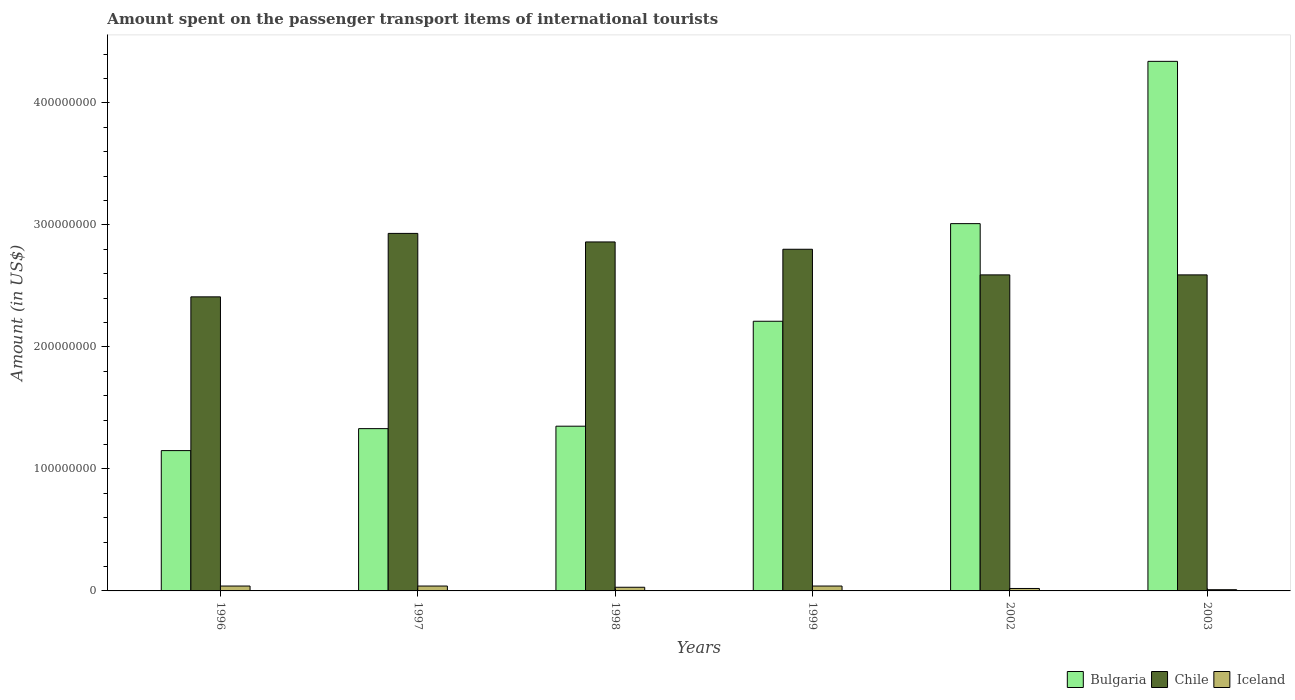How many groups of bars are there?
Your answer should be very brief. 6. Are the number of bars per tick equal to the number of legend labels?
Offer a very short reply. Yes. Are the number of bars on each tick of the X-axis equal?
Your answer should be very brief. Yes. How many bars are there on the 4th tick from the left?
Give a very brief answer. 3. How many bars are there on the 4th tick from the right?
Provide a short and direct response. 3. In how many cases, is the number of bars for a given year not equal to the number of legend labels?
Provide a short and direct response. 0. What is the amount spent on the passenger transport items of international tourists in Bulgaria in 2003?
Make the answer very short. 4.34e+08. Across all years, what is the maximum amount spent on the passenger transport items of international tourists in Bulgaria?
Your answer should be very brief. 4.34e+08. Across all years, what is the minimum amount spent on the passenger transport items of international tourists in Bulgaria?
Provide a short and direct response. 1.15e+08. What is the total amount spent on the passenger transport items of international tourists in Chile in the graph?
Offer a terse response. 1.62e+09. What is the difference between the amount spent on the passenger transport items of international tourists in Bulgaria in 2002 and that in 2003?
Give a very brief answer. -1.33e+08. What is the difference between the amount spent on the passenger transport items of international tourists in Iceland in 1999 and the amount spent on the passenger transport items of international tourists in Bulgaria in 1996?
Ensure brevity in your answer.  -1.11e+08. What is the average amount spent on the passenger transport items of international tourists in Iceland per year?
Keep it short and to the point. 3.00e+06. In the year 2003, what is the difference between the amount spent on the passenger transport items of international tourists in Iceland and amount spent on the passenger transport items of international tourists in Bulgaria?
Your response must be concise. -4.33e+08. In how many years, is the amount spent on the passenger transport items of international tourists in Bulgaria greater than 220000000 US$?
Provide a succinct answer. 3. What is the ratio of the amount spent on the passenger transport items of international tourists in Bulgaria in 2002 to that in 2003?
Your answer should be compact. 0.69. Is the amount spent on the passenger transport items of international tourists in Bulgaria in 1997 less than that in 2003?
Keep it short and to the point. Yes. Is the difference between the amount spent on the passenger transport items of international tourists in Iceland in 1996 and 1998 greater than the difference between the amount spent on the passenger transport items of international tourists in Bulgaria in 1996 and 1998?
Ensure brevity in your answer.  Yes. What is the difference between the highest and the second highest amount spent on the passenger transport items of international tourists in Iceland?
Your answer should be very brief. 0. What is the difference between the highest and the lowest amount spent on the passenger transport items of international tourists in Iceland?
Offer a very short reply. 3.00e+06. In how many years, is the amount spent on the passenger transport items of international tourists in Bulgaria greater than the average amount spent on the passenger transport items of international tourists in Bulgaria taken over all years?
Give a very brief answer. 2. Is the sum of the amount spent on the passenger transport items of international tourists in Bulgaria in 1999 and 2002 greater than the maximum amount spent on the passenger transport items of international tourists in Iceland across all years?
Offer a terse response. Yes. What does the 2nd bar from the left in 2003 represents?
Your response must be concise. Chile. What does the 2nd bar from the right in 1997 represents?
Provide a succinct answer. Chile. Is it the case that in every year, the sum of the amount spent on the passenger transport items of international tourists in Chile and amount spent on the passenger transport items of international tourists in Iceland is greater than the amount spent on the passenger transport items of international tourists in Bulgaria?
Give a very brief answer. No. Are all the bars in the graph horizontal?
Ensure brevity in your answer.  No. How many years are there in the graph?
Your answer should be compact. 6. What is the difference between two consecutive major ticks on the Y-axis?
Provide a succinct answer. 1.00e+08. Does the graph contain any zero values?
Your response must be concise. No. Does the graph contain grids?
Provide a succinct answer. No. Where does the legend appear in the graph?
Give a very brief answer. Bottom right. What is the title of the graph?
Offer a very short reply. Amount spent on the passenger transport items of international tourists. What is the label or title of the X-axis?
Offer a very short reply. Years. What is the Amount (in US$) in Bulgaria in 1996?
Your response must be concise. 1.15e+08. What is the Amount (in US$) of Chile in 1996?
Your response must be concise. 2.41e+08. What is the Amount (in US$) of Bulgaria in 1997?
Your answer should be very brief. 1.33e+08. What is the Amount (in US$) of Chile in 1997?
Provide a succinct answer. 2.93e+08. What is the Amount (in US$) in Iceland in 1997?
Your answer should be compact. 4.00e+06. What is the Amount (in US$) of Bulgaria in 1998?
Provide a succinct answer. 1.35e+08. What is the Amount (in US$) in Chile in 1998?
Your answer should be very brief. 2.86e+08. What is the Amount (in US$) in Bulgaria in 1999?
Your answer should be compact. 2.21e+08. What is the Amount (in US$) in Chile in 1999?
Your answer should be very brief. 2.80e+08. What is the Amount (in US$) of Iceland in 1999?
Provide a succinct answer. 4.00e+06. What is the Amount (in US$) of Bulgaria in 2002?
Your response must be concise. 3.01e+08. What is the Amount (in US$) in Chile in 2002?
Offer a terse response. 2.59e+08. What is the Amount (in US$) of Iceland in 2002?
Keep it short and to the point. 2.00e+06. What is the Amount (in US$) in Bulgaria in 2003?
Keep it short and to the point. 4.34e+08. What is the Amount (in US$) of Chile in 2003?
Your answer should be compact. 2.59e+08. What is the Amount (in US$) of Iceland in 2003?
Provide a short and direct response. 1.00e+06. Across all years, what is the maximum Amount (in US$) in Bulgaria?
Provide a short and direct response. 4.34e+08. Across all years, what is the maximum Amount (in US$) of Chile?
Keep it short and to the point. 2.93e+08. Across all years, what is the maximum Amount (in US$) in Iceland?
Your answer should be compact. 4.00e+06. Across all years, what is the minimum Amount (in US$) in Bulgaria?
Give a very brief answer. 1.15e+08. Across all years, what is the minimum Amount (in US$) of Chile?
Your answer should be very brief. 2.41e+08. What is the total Amount (in US$) in Bulgaria in the graph?
Give a very brief answer. 1.34e+09. What is the total Amount (in US$) of Chile in the graph?
Make the answer very short. 1.62e+09. What is the total Amount (in US$) of Iceland in the graph?
Provide a succinct answer. 1.80e+07. What is the difference between the Amount (in US$) of Bulgaria in 1996 and that in 1997?
Keep it short and to the point. -1.80e+07. What is the difference between the Amount (in US$) of Chile in 1996 and that in 1997?
Your response must be concise. -5.20e+07. What is the difference between the Amount (in US$) of Bulgaria in 1996 and that in 1998?
Give a very brief answer. -2.00e+07. What is the difference between the Amount (in US$) in Chile in 1996 and that in 1998?
Offer a terse response. -4.50e+07. What is the difference between the Amount (in US$) of Iceland in 1996 and that in 1998?
Give a very brief answer. 1.00e+06. What is the difference between the Amount (in US$) of Bulgaria in 1996 and that in 1999?
Your response must be concise. -1.06e+08. What is the difference between the Amount (in US$) of Chile in 1996 and that in 1999?
Give a very brief answer. -3.90e+07. What is the difference between the Amount (in US$) of Bulgaria in 1996 and that in 2002?
Your response must be concise. -1.86e+08. What is the difference between the Amount (in US$) in Chile in 1996 and that in 2002?
Your answer should be very brief. -1.80e+07. What is the difference between the Amount (in US$) of Bulgaria in 1996 and that in 2003?
Offer a very short reply. -3.19e+08. What is the difference between the Amount (in US$) in Chile in 1996 and that in 2003?
Your response must be concise. -1.80e+07. What is the difference between the Amount (in US$) in Iceland in 1996 and that in 2003?
Make the answer very short. 3.00e+06. What is the difference between the Amount (in US$) in Chile in 1997 and that in 1998?
Offer a very short reply. 7.00e+06. What is the difference between the Amount (in US$) of Iceland in 1997 and that in 1998?
Provide a succinct answer. 1.00e+06. What is the difference between the Amount (in US$) of Bulgaria in 1997 and that in 1999?
Your answer should be very brief. -8.80e+07. What is the difference between the Amount (in US$) in Chile in 1997 and that in 1999?
Provide a short and direct response. 1.30e+07. What is the difference between the Amount (in US$) in Iceland in 1997 and that in 1999?
Ensure brevity in your answer.  0. What is the difference between the Amount (in US$) of Bulgaria in 1997 and that in 2002?
Make the answer very short. -1.68e+08. What is the difference between the Amount (in US$) in Chile in 1997 and that in 2002?
Keep it short and to the point. 3.40e+07. What is the difference between the Amount (in US$) of Iceland in 1997 and that in 2002?
Keep it short and to the point. 2.00e+06. What is the difference between the Amount (in US$) of Bulgaria in 1997 and that in 2003?
Provide a short and direct response. -3.01e+08. What is the difference between the Amount (in US$) of Chile in 1997 and that in 2003?
Your response must be concise. 3.40e+07. What is the difference between the Amount (in US$) in Iceland in 1997 and that in 2003?
Your answer should be compact. 3.00e+06. What is the difference between the Amount (in US$) in Bulgaria in 1998 and that in 1999?
Keep it short and to the point. -8.60e+07. What is the difference between the Amount (in US$) in Bulgaria in 1998 and that in 2002?
Provide a short and direct response. -1.66e+08. What is the difference between the Amount (in US$) in Chile in 1998 and that in 2002?
Offer a very short reply. 2.70e+07. What is the difference between the Amount (in US$) of Bulgaria in 1998 and that in 2003?
Provide a succinct answer. -2.99e+08. What is the difference between the Amount (in US$) in Chile in 1998 and that in 2003?
Give a very brief answer. 2.70e+07. What is the difference between the Amount (in US$) of Iceland in 1998 and that in 2003?
Your answer should be very brief. 2.00e+06. What is the difference between the Amount (in US$) of Bulgaria in 1999 and that in 2002?
Offer a very short reply. -8.00e+07. What is the difference between the Amount (in US$) in Chile in 1999 and that in 2002?
Your answer should be compact. 2.10e+07. What is the difference between the Amount (in US$) in Bulgaria in 1999 and that in 2003?
Offer a very short reply. -2.13e+08. What is the difference between the Amount (in US$) in Chile in 1999 and that in 2003?
Ensure brevity in your answer.  2.10e+07. What is the difference between the Amount (in US$) of Bulgaria in 2002 and that in 2003?
Keep it short and to the point. -1.33e+08. What is the difference between the Amount (in US$) in Chile in 2002 and that in 2003?
Give a very brief answer. 0. What is the difference between the Amount (in US$) in Iceland in 2002 and that in 2003?
Your answer should be very brief. 1.00e+06. What is the difference between the Amount (in US$) in Bulgaria in 1996 and the Amount (in US$) in Chile in 1997?
Make the answer very short. -1.78e+08. What is the difference between the Amount (in US$) of Bulgaria in 1996 and the Amount (in US$) of Iceland in 1997?
Your answer should be very brief. 1.11e+08. What is the difference between the Amount (in US$) in Chile in 1996 and the Amount (in US$) in Iceland in 1997?
Your answer should be very brief. 2.37e+08. What is the difference between the Amount (in US$) in Bulgaria in 1996 and the Amount (in US$) in Chile in 1998?
Provide a short and direct response. -1.71e+08. What is the difference between the Amount (in US$) of Bulgaria in 1996 and the Amount (in US$) of Iceland in 1998?
Give a very brief answer. 1.12e+08. What is the difference between the Amount (in US$) in Chile in 1996 and the Amount (in US$) in Iceland in 1998?
Your answer should be compact. 2.38e+08. What is the difference between the Amount (in US$) of Bulgaria in 1996 and the Amount (in US$) of Chile in 1999?
Provide a short and direct response. -1.65e+08. What is the difference between the Amount (in US$) of Bulgaria in 1996 and the Amount (in US$) of Iceland in 1999?
Keep it short and to the point. 1.11e+08. What is the difference between the Amount (in US$) in Chile in 1996 and the Amount (in US$) in Iceland in 1999?
Ensure brevity in your answer.  2.37e+08. What is the difference between the Amount (in US$) in Bulgaria in 1996 and the Amount (in US$) in Chile in 2002?
Your response must be concise. -1.44e+08. What is the difference between the Amount (in US$) in Bulgaria in 1996 and the Amount (in US$) in Iceland in 2002?
Provide a short and direct response. 1.13e+08. What is the difference between the Amount (in US$) of Chile in 1996 and the Amount (in US$) of Iceland in 2002?
Ensure brevity in your answer.  2.39e+08. What is the difference between the Amount (in US$) in Bulgaria in 1996 and the Amount (in US$) in Chile in 2003?
Offer a terse response. -1.44e+08. What is the difference between the Amount (in US$) of Bulgaria in 1996 and the Amount (in US$) of Iceland in 2003?
Your answer should be very brief. 1.14e+08. What is the difference between the Amount (in US$) of Chile in 1996 and the Amount (in US$) of Iceland in 2003?
Give a very brief answer. 2.40e+08. What is the difference between the Amount (in US$) in Bulgaria in 1997 and the Amount (in US$) in Chile in 1998?
Your answer should be very brief. -1.53e+08. What is the difference between the Amount (in US$) in Bulgaria in 1997 and the Amount (in US$) in Iceland in 1998?
Make the answer very short. 1.30e+08. What is the difference between the Amount (in US$) in Chile in 1997 and the Amount (in US$) in Iceland in 1998?
Your response must be concise. 2.90e+08. What is the difference between the Amount (in US$) of Bulgaria in 1997 and the Amount (in US$) of Chile in 1999?
Offer a very short reply. -1.47e+08. What is the difference between the Amount (in US$) of Bulgaria in 1997 and the Amount (in US$) of Iceland in 1999?
Your answer should be very brief. 1.29e+08. What is the difference between the Amount (in US$) in Chile in 1997 and the Amount (in US$) in Iceland in 1999?
Make the answer very short. 2.89e+08. What is the difference between the Amount (in US$) of Bulgaria in 1997 and the Amount (in US$) of Chile in 2002?
Your answer should be compact. -1.26e+08. What is the difference between the Amount (in US$) in Bulgaria in 1997 and the Amount (in US$) in Iceland in 2002?
Give a very brief answer. 1.31e+08. What is the difference between the Amount (in US$) in Chile in 1997 and the Amount (in US$) in Iceland in 2002?
Ensure brevity in your answer.  2.91e+08. What is the difference between the Amount (in US$) in Bulgaria in 1997 and the Amount (in US$) in Chile in 2003?
Your response must be concise. -1.26e+08. What is the difference between the Amount (in US$) of Bulgaria in 1997 and the Amount (in US$) of Iceland in 2003?
Make the answer very short. 1.32e+08. What is the difference between the Amount (in US$) in Chile in 1997 and the Amount (in US$) in Iceland in 2003?
Ensure brevity in your answer.  2.92e+08. What is the difference between the Amount (in US$) in Bulgaria in 1998 and the Amount (in US$) in Chile in 1999?
Your response must be concise. -1.45e+08. What is the difference between the Amount (in US$) in Bulgaria in 1998 and the Amount (in US$) in Iceland in 1999?
Your answer should be compact. 1.31e+08. What is the difference between the Amount (in US$) of Chile in 1998 and the Amount (in US$) of Iceland in 1999?
Your response must be concise. 2.82e+08. What is the difference between the Amount (in US$) in Bulgaria in 1998 and the Amount (in US$) in Chile in 2002?
Provide a succinct answer. -1.24e+08. What is the difference between the Amount (in US$) of Bulgaria in 1998 and the Amount (in US$) of Iceland in 2002?
Offer a terse response. 1.33e+08. What is the difference between the Amount (in US$) in Chile in 1998 and the Amount (in US$) in Iceland in 2002?
Provide a short and direct response. 2.84e+08. What is the difference between the Amount (in US$) of Bulgaria in 1998 and the Amount (in US$) of Chile in 2003?
Offer a terse response. -1.24e+08. What is the difference between the Amount (in US$) of Bulgaria in 1998 and the Amount (in US$) of Iceland in 2003?
Your answer should be very brief. 1.34e+08. What is the difference between the Amount (in US$) in Chile in 1998 and the Amount (in US$) in Iceland in 2003?
Your response must be concise. 2.85e+08. What is the difference between the Amount (in US$) in Bulgaria in 1999 and the Amount (in US$) in Chile in 2002?
Offer a very short reply. -3.80e+07. What is the difference between the Amount (in US$) of Bulgaria in 1999 and the Amount (in US$) of Iceland in 2002?
Offer a terse response. 2.19e+08. What is the difference between the Amount (in US$) in Chile in 1999 and the Amount (in US$) in Iceland in 2002?
Make the answer very short. 2.78e+08. What is the difference between the Amount (in US$) of Bulgaria in 1999 and the Amount (in US$) of Chile in 2003?
Your response must be concise. -3.80e+07. What is the difference between the Amount (in US$) in Bulgaria in 1999 and the Amount (in US$) in Iceland in 2003?
Provide a short and direct response. 2.20e+08. What is the difference between the Amount (in US$) of Chile in 1999 and the Amount (in US$) of Iceland in 2003?
Give a very brief answer. 2.79e+08. What is the difference between the Amount (in US$) of Bulgaria in 2002 and the Amount (in US$) of Chile in 2003?
Keep it short and to the point. 4.20e+07. What is the difference between the Amount (in US$) of Bulgaria in 2002 and the Amount (in US$) of Iceland in 2003?
Keep it short and to the point. 3.00e+08. What is the difference between the Amount (in US$) in Chile in 2002 and the Amount (in US$) in Iceland in 2003?
Provide a succinct answer. 2.58e+08. What is the average Amount (in US$) in Bulgaria per year?
Provide a short and direct response. 2.23e+08. What is the average Amount (in US$) of Chile per year?
Offer a very short reply. 2.70e+08. What is the average Amount (in US$) in Iceland per year?
Your answer should be very brief. 3.00e+06. In the year 1996, what is the difference between the Amount (in US$) in Bulgaria and Amount (in US$) in Chile?
Give a very brief answer. -1.26e+08. In the year 1996, what is the difference between the Amount (in US$) of Bulgaria and Amount (in US$) of Iceland?
Provide a succinct answer. 1.11e+08. In the year 1996, what is the difference between the Amount (in US$) of Chile and Amount (in US$) of Iceland?
Your answer should be very brief. 2.37e+08. In the year 1997, what is the difference between the Amount (in US$) in Bulgaria and Amount (in US$) in Chile?
Your answer should be very brief. -1.60e+08. In the year 1997, what is the difference between the Amount (in US$) in Bulgaria and Amount (in US$) in Iceland?
Offer a terse response. 1.29e+08. In the year 1997, what is the difference between the Amount (in US$) of Chile and Amount (in US$) of Iceland?
Your response must be concise. 2.89e+08. In the year 1998, what is the difference between the Amount (in US$) of Bulgaria and Amount (in US$) of Chile?
Offer a very short reply. -1.51e+08. In the year 1998, what is the difference between the Amount (in US$) in Bulgaria and Amount (in US$) in Iceland?
Offer a terse response. 1.32e+08. In the year 1998, what is the difference between the Amount (in US$) in Chile and Amount (in US$) in Iceland?
Ensure brevity in your answer.  2.83e+08. In the year 1999, what is the difference between the Amount (in US$) of Bulgaria and Amount (in US$) of Chile?
Your answer should be compact. -5.90e+07. In the year 1999, what is the difference between the Amount (in US$) of Bulgaria and Amount (in US$) of Iceland?
Give a very brief answer. 2.17e+08. In the year 1999, what is the difference between the Amount (in US$) in Chile and Amount (in US$) in Iceland?
Make the answer very short. 2.76e+08. In the year 2002, what is the difference between the Amount (in US$) of Bulgaria and Amount (in US$) of Chile?
Ensure brevity in your answer.  4.20e+07. In the year 2002, what is the difference between the Amount (in US$) in Bulgaria and Amount (in US$) in Iceland?
Give a very brief answer. 2.99e+08. In the year 2002, what is the difference between the Amount (in US$) in Chile and Amount (in US$) in Iceland?
Your answer should be compact. 2.57e+08. In the year 2003, what is the difference between the Amount (in US$) of Bulgaria and Amount (in US$) of Chile?
Your answer should be very brief. 1.75e+08. In the year 2003, what is the difference between the Amount (in US$) in Bulgaria and Amount (in US$) in Iceland?
Your answer should be compact. 4.33e+08. In the year 2003, what is the difference between the Amount (in US$) of Chile and Amount (in US$) of Iceland?
Offer a terse response. 2.58e+08. What is the ratio of the Amount (in US$) of Bulgaria in 1996 to that in 1997?
Provide a succinct answer. 0.86. What is the ratio of the Amount (in US$) in Chile in 1996 to that in 1997?
Ensure brevity in your answer.  0.82. What is the ratio of the Amount (in US$) of Iceland in 1996 to that in 1997?
Offer a terse response. 1. What is the ratio of the Amount (in US$) of Bulgaria in 1996 to that in 1998?
Give a very brief answer. 0.85. What is the ratio of the Amount (in US$) in Chile in 1996 to that in 1998?
Give a very brief answer. 0.84. What is the ratio of the Amount (in US$) in Bulgaria in 1996 to that in 1999?
Provide a succinct answer. 0.52. What is the ratio of the Amount (in US$) in Chile in 1996 to that in 1999?
Your response must be concise. 0.86. What is the ratio of the Amount (in US$) of Bulgaria in 1996 to that in 2002?
Offer a terse response. 0.38. What is the ratio of the Amount (in US$) in Chile in 1996 to that in 2002?
Your answer should be compact. 0.93. What is the ratio of the Amount (in US$) in Iceland in 1996 to that in 2002?
Ensure brevity in your answer.  2. What is the ratio of the Amount (in US$) of Bulgaria in 1996 to that in 2003?
Your answer should be compact. 0.27. What is the ratio of the Amount (in US$) in Chile in 1996 to that in 2003?
Your response must be concise. 0.93. What is the ratio of the Amount (in US$) of Iceland in 1996 to that in 2003?
Offer a very short reply. 4. What is the ratio of the Amount (in US$) in Bulgaria in 1997 to that in 1998?
Provide a succinct answer. 0.99. What is the ratio of the Amount (in US$) in Chile in 1997 to that in 1998?
Your response must be concise. 1.02. What is the ratio of the Amount (in US$) in Iceland in 1997 to that in 1998?
Provide a succinct answer. 1.33. What is the ratio of the Amount (in US$) in Bulgaria in 1997 to that in 1999?
Provide a succinct answer. 0.6. What is the ratio of the Amount (in US$) of Chile in 1997 to that in 1999?
Provide a short and direct response. 1.05. What is the ratio of the Amount (in US$) of Bulgaria in 1997 to that in 2002?
Offer a terse response. 0.44. What is the ratio of the Amount (in US$) in Chile in 1997 to that in 2002?
Your response must be concise. 1.13. What is the ratio of the Amount (in US$) in Bulgaria in 1997 to that in 2003?
Keep it short and to the point. 0.31. What is the ratio of the Amount (in US$) in Chile in 1997 to that in 2003?
Your response must be concise. 1.13. What is the ratio of the Amount (in US$) in Iceland in 1997 to that in 2003?
Your answer should be very brief. 4. What is the ratio of the Amount (in US$) of Bulgaria in 1998 to that in 1999?
Offer a very short reply. 0.61. What is the ratio of the Amount (in US$) in Chile in 1998 to that in 1999?
Your answer should be compact. 1.02. What is the ratio of the Amount (in US$) in Bulgaria in 1998 to that in 2002?
Make the answer very short. 0.45. What is the ratio of the Amount (in US$) in Chile in 1998 to that in 2002?
Make the answer very short. 1.1. What is the ratio of the Amount (in US$) of Bulgaria in 1998 to that in 2003?
Ensure brevity in your answer.  0.31. What is the ratio of the Amount (in US$) of Chile in 1998 to that in 2003?
Your answer should be very brief. 1.1. What is the ratio of the Amount (in US$) in Iceland in 1998 to that in 2003?
Keep it short and to the point. 3. What is the ratio of the Amount (in US$) of Bulgaria in 1999 to that in 2002?
Provide a succinct answer. 0.73. What is the ratio of the Amount (in US$) in Chile in 1999 to that in 2002?
Offer a terse response. 1.08. What is the ratio of the Amount (in US$) of Bulgaria in 1999 to that in 2003?
Give a very brief answer. 0.51. What is the ratio of the Amount (in US$) of Chile in 1999 to that in 2003?
Provide a short and direct response. 1.08. What is the ratio of the Amount (in US$) in Bulgaria in 2002 to that in 2003?
Make the answer very short. 0.69. What is the difference between the highest and the second highest Amount (in US$) in Bulgaria?
Your answer should be very brief. 1.33e+08. What is the difference between the highest and the second highest Amount (in US$) in Chile?
Your answer should be very brief. 7.00e+06. What is the difference between the highest and the lowest Amount (in US$) in Bulgaria?
Keep it short and to the point. 3.19e+08. What is the difference between the highest and the lowest Amount (in US$) of Chile?
Keep it short and to the point. 5.20e+07. 